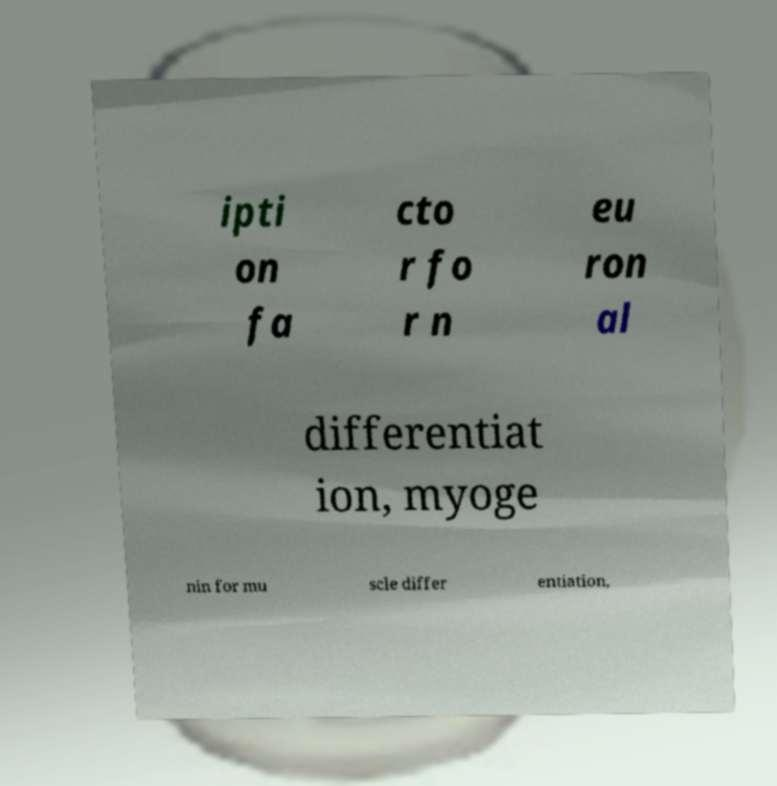Please identify and transcribe the text found in this image. ipti on fa cto r fo r n eu ron al differentiat ion, myoge nin for mu scle differ entiation, 